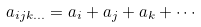Convert formula to latex. <formula><loc_0><loc_0><loc_500><loc_500>a _ { i j k \dots } = a _ { i } + a _ { j } + a _ { k } + \cdots</formula> 